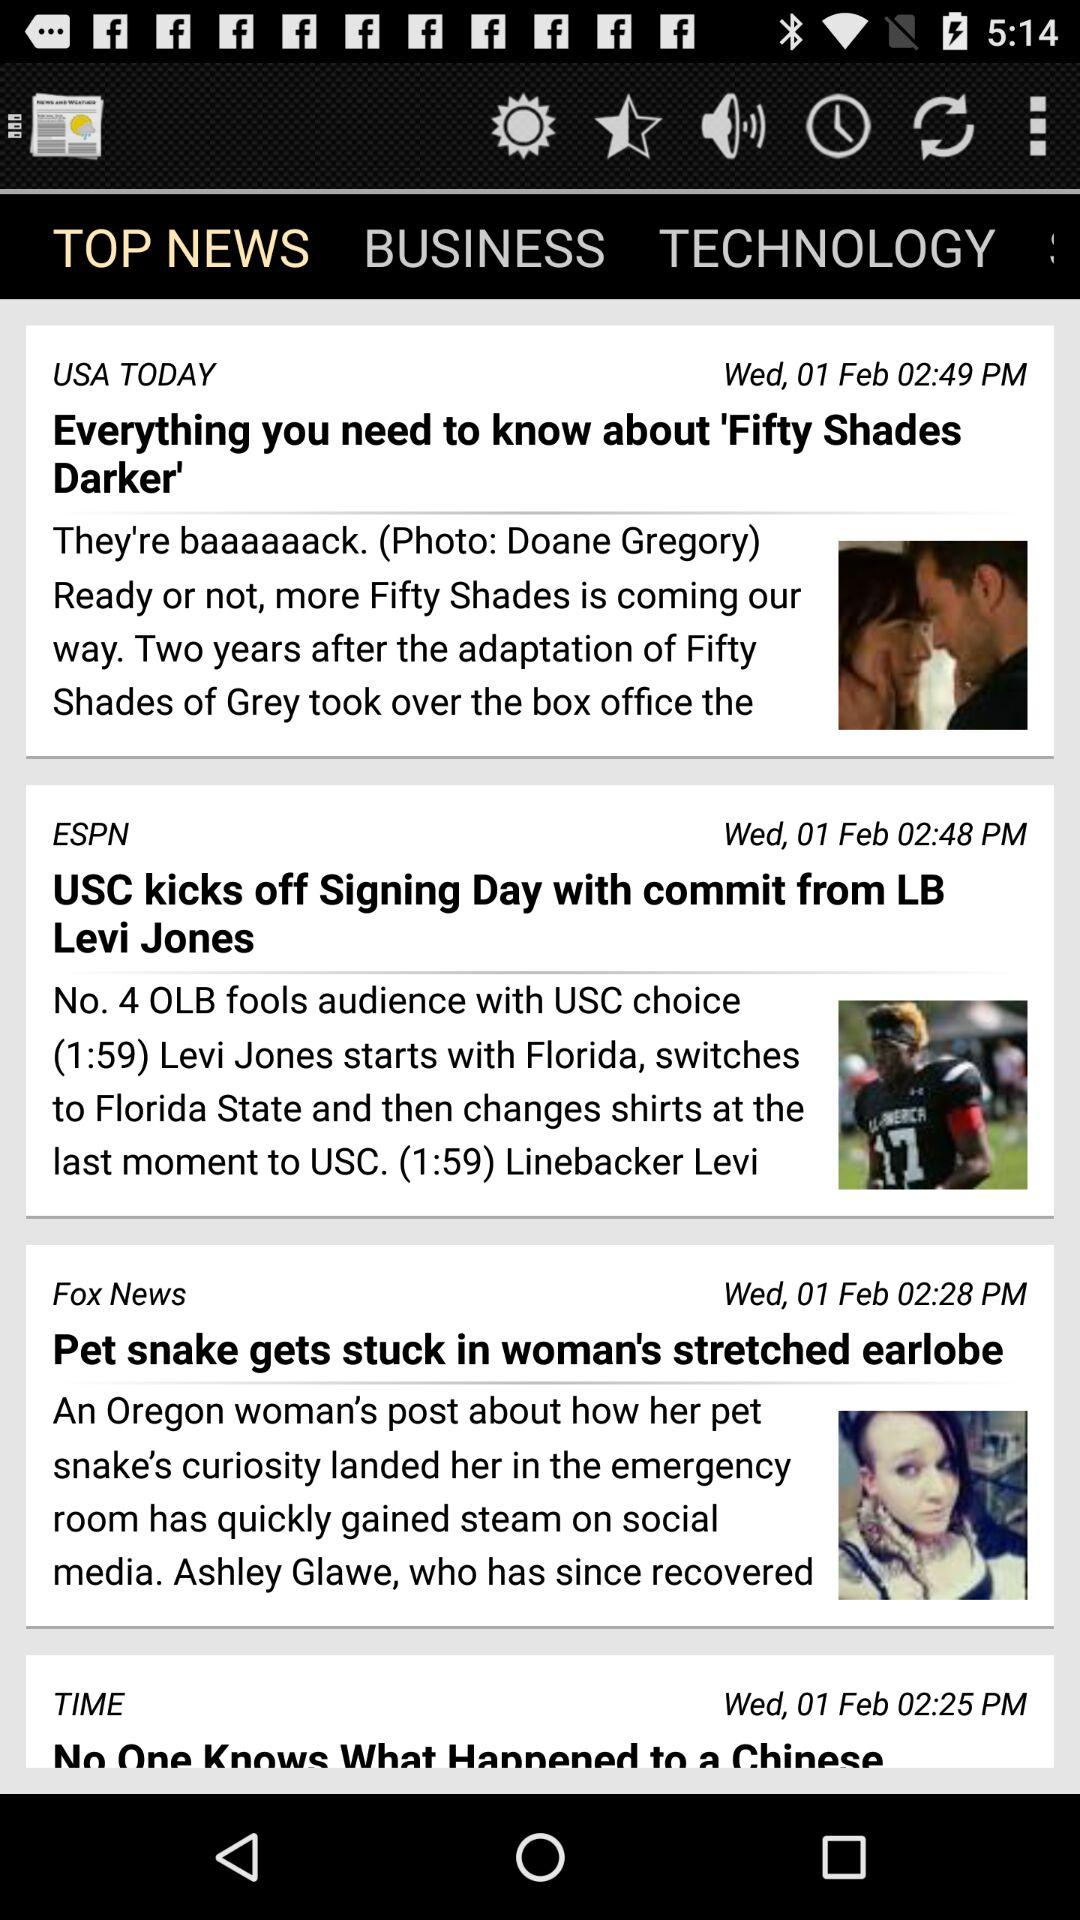Which tab is selected? The selected tab is "TOP NEWS". 